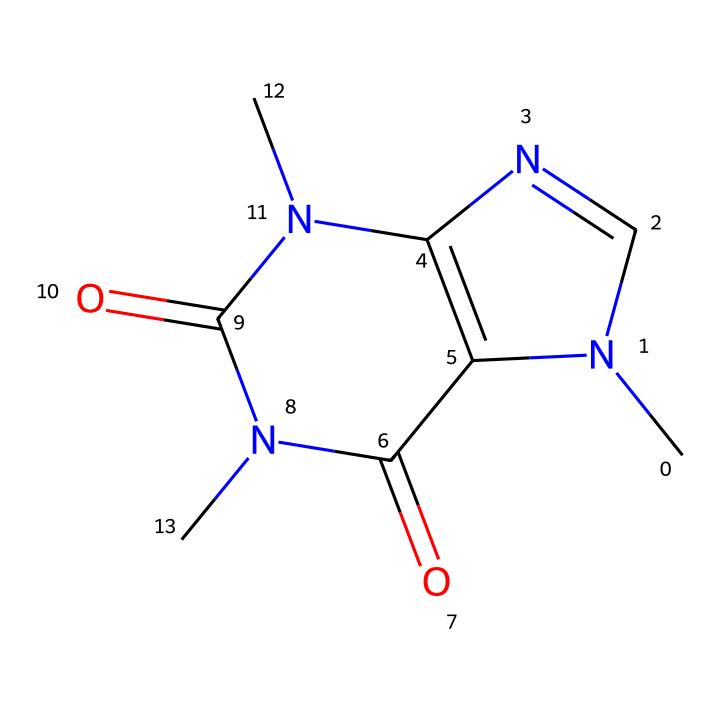What is the molecular formula of this chemical? By analyzing the SMILES representation, we can count the atoms present: There are 8 carbon (C) atoms, 10 hydrogen (H) atoms, 4 nitrogen (N) atoms, and 2 oxygen (O) atoms. Thus, the molecular formula is C8H10N4O2.
Answer: C8H10N4O2 How many nitrogen atoms are in the chemical structure? From the SMILES, we can see there are four occurrences of 'N'. Therefore, the chemical structure contains four nitrogen atoms.
Answer: 4 What kind of chemical is caffeine categorized as? The structure indicates the presence of nitrogen atoms and rings, which are characteristics of alkaloids. Hence, caffeine is classified as an alkaloid.
Answer: alkaloid Does this chemical have any double bonds? Upon examining the structure in the SMILES representation, we note multiple '=' symbols indicating double bonds between some carbon and oxygen atoms, which confirms the presence of double bonds.
Answer: yes What is the functional group present in caffeine? The structure shows carbonyl groups (C=O) along with nitrogen functionalities, typical of amides and purines, which are classes of compounds caffeine belongs to.
Answer: carbonyl Which part of this chemical structure contributes to its stimulant properties? The presence of nitrogen atoms in the cyclic structure along with other components contributes to the physiological effects of caffeine, hence being identified as a stimulant.
Answer: nitrogen atoms 